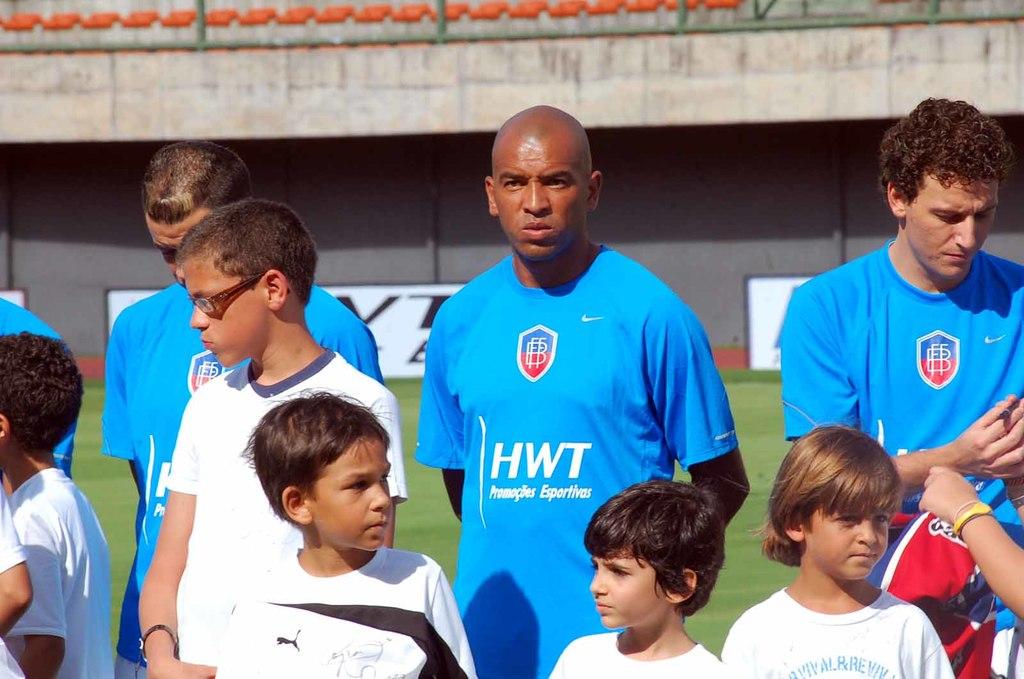What is written on the black man's shirt?
Your response must be concise. Hwt. What three letters name the team?
Give a very brief answer. Hwt. 